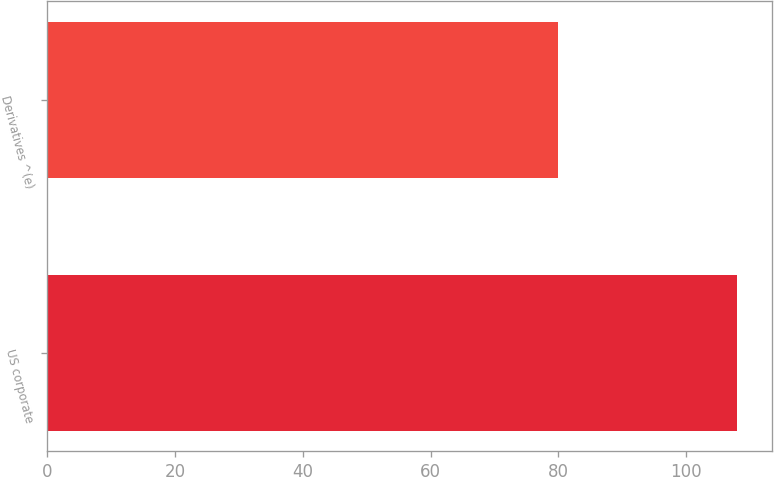Convert chart. <chart><loc_0><loc_0><loc_500><loc_500><bar_chart><fcel>US corporate<fcel>Derivatives ^(e)<nl><fcel>108<fcel>80<nl></chart> 